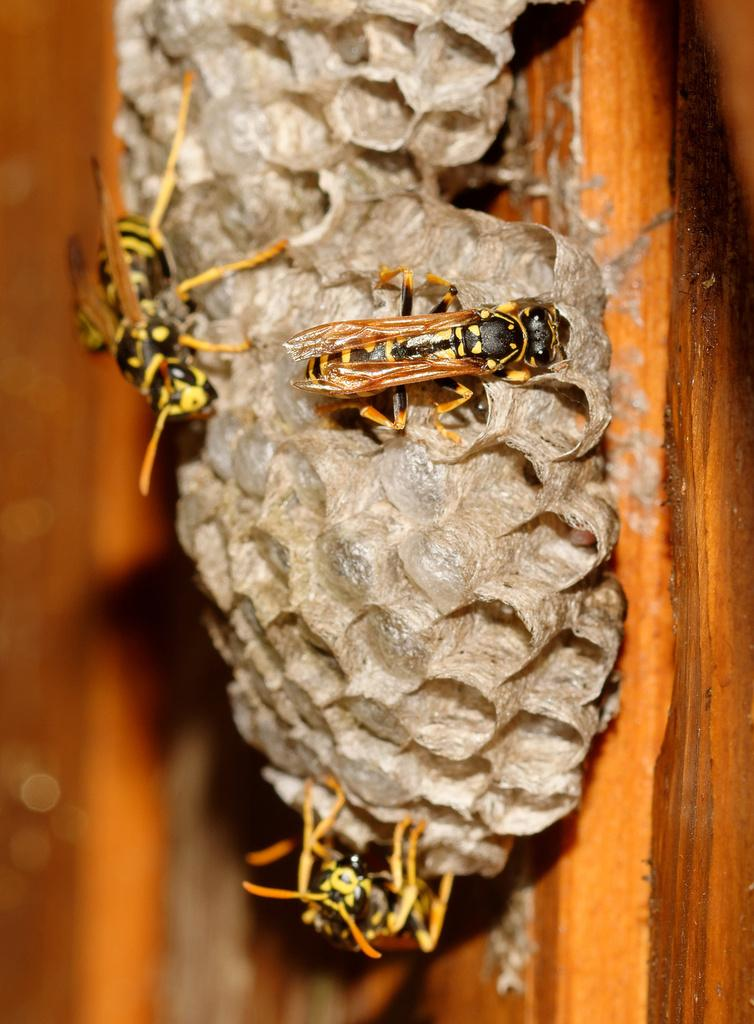What is the main object in the image? There is a wooden plank in the image. What is on top of the wooden plank? There is a honeycomb on the wooden plank. How many honey bees can be seen on the honeycomb? There are three honey bees on the honeycomb. What type of celery is being used as a decoration in the image? There is no celery present in the image. 